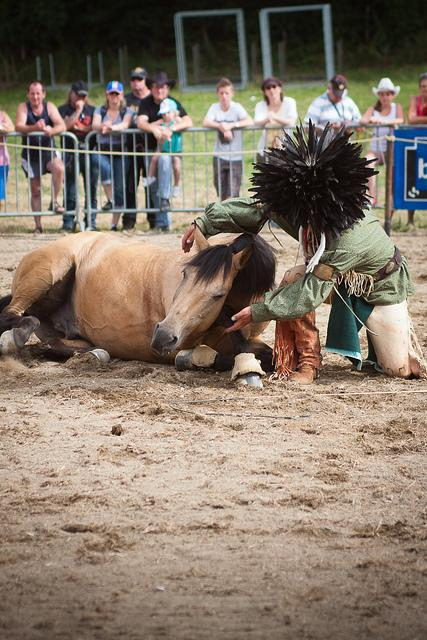Most horses that are used for racing are ridden by professional riders called as? jockeys 